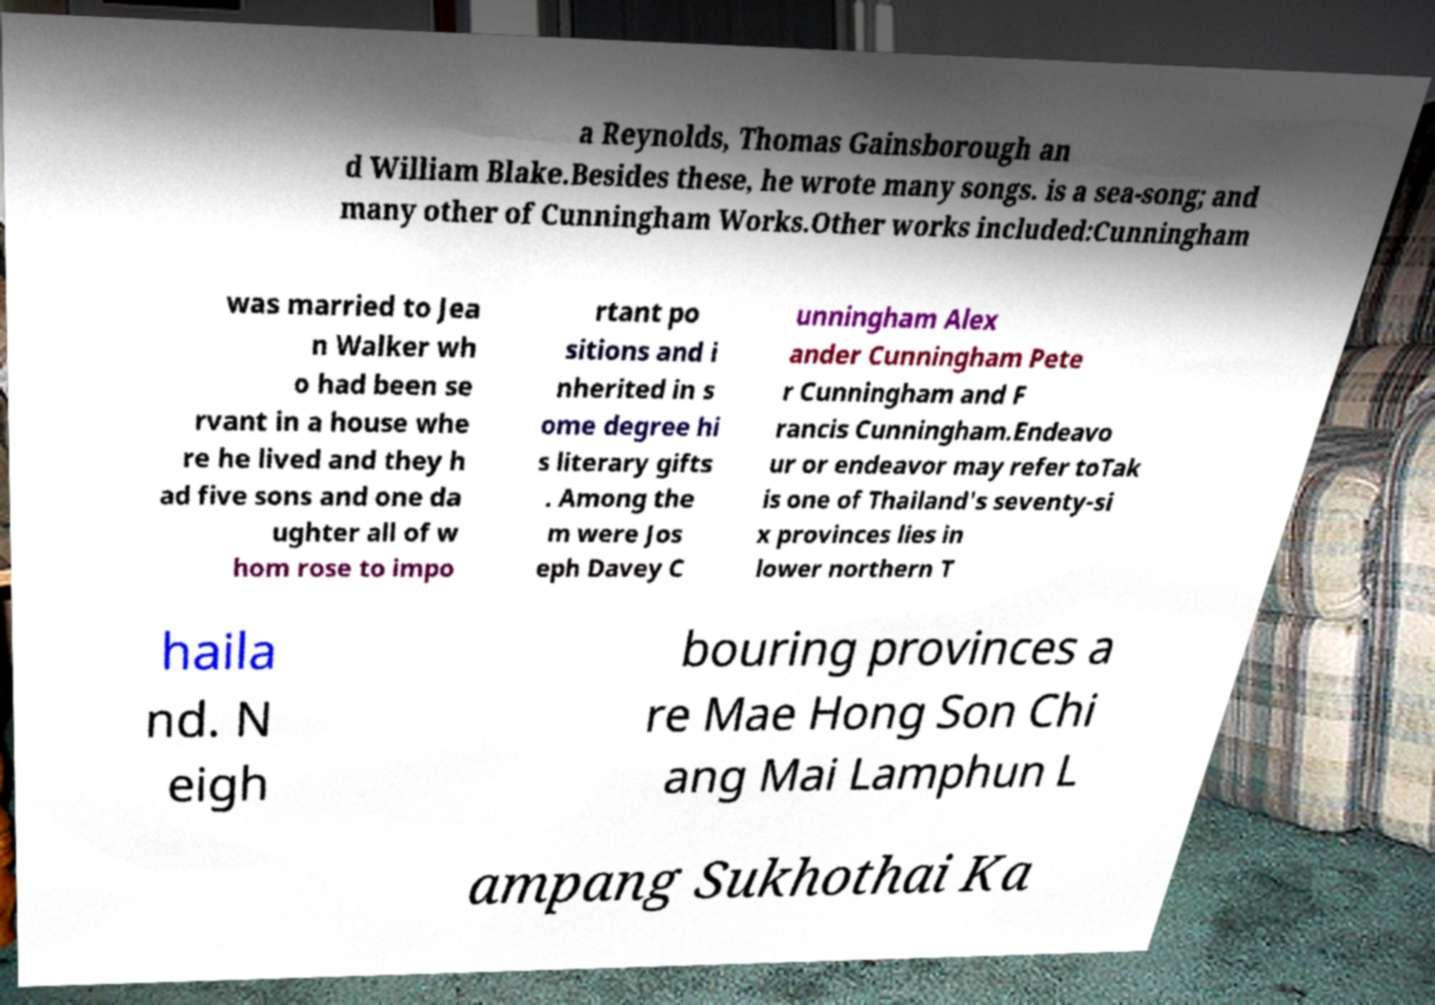For documentation purposes, I need the text within this image transcribed. Could you provide that? a Reynolds, Thomas Gainsborough an d William Blake.Besides these, he wrote many songs. is a sea-song; and many other of Cunningham Works.Other works included:Cunningham was married to Jea n Walker wh o had been se rvant in a house whe re he lived and they h ad five sons and one da ughter all of w hom rose to impo rtant po sitions and i nherited in s ome degree hi s literary gifts . Among the m were Jos eph Davey C unningham Alex ander Cunningham Pete r Cunningham and F rancis Cunningham.Endeavo ur or endeavor may refer toTak is one of Thailand's seventy-si x provinces lies in lower northern T haila nd. N eigh bouring provinces a re Mae Hong Son Chi ang Mai Lamphun L ampang Sukhothai Ka 